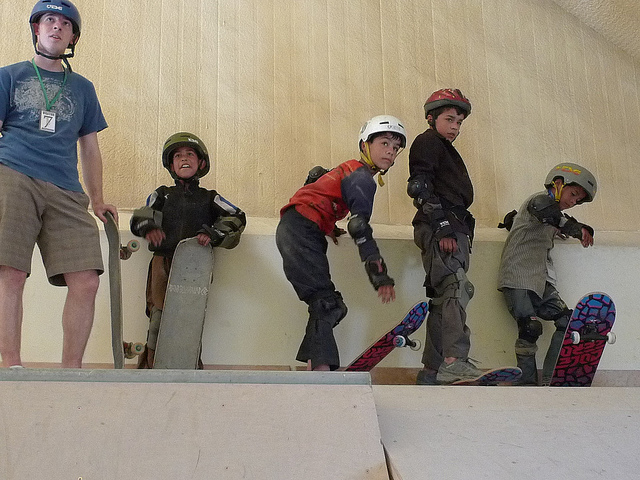Extract all visible text content from this image. 7 